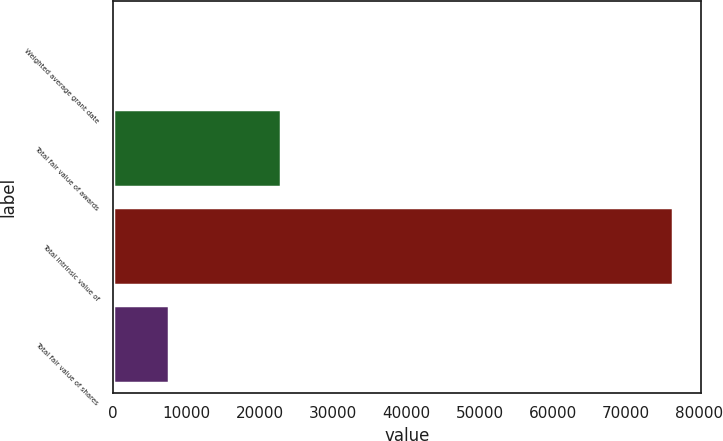Convert chart to OTSL. <chart><loc_0><loc_0><loc_500><loc_500><bar_chart><fcel>Weighted average grant date<fcel>Total fair value of awards<fcel>Total intrinsic value of<fcel>Total fair value of shares<nl><fcel>7.23<fcel>22939.2<fcel>76447<fcel>7651.21<nl></chart> 